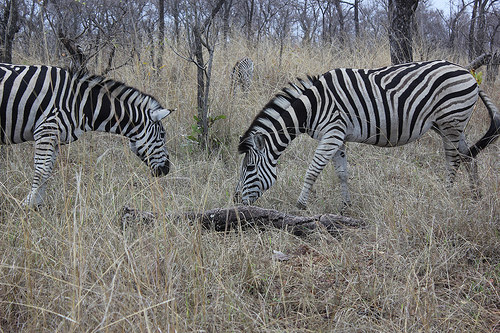What time of year does this picture seem to represent? The picture likely represents the dry season, as evidenced by the yellowed, parched grasses and the lack of lush greenery, which would be characteristic of the wet season in the savanna where zebras live. 